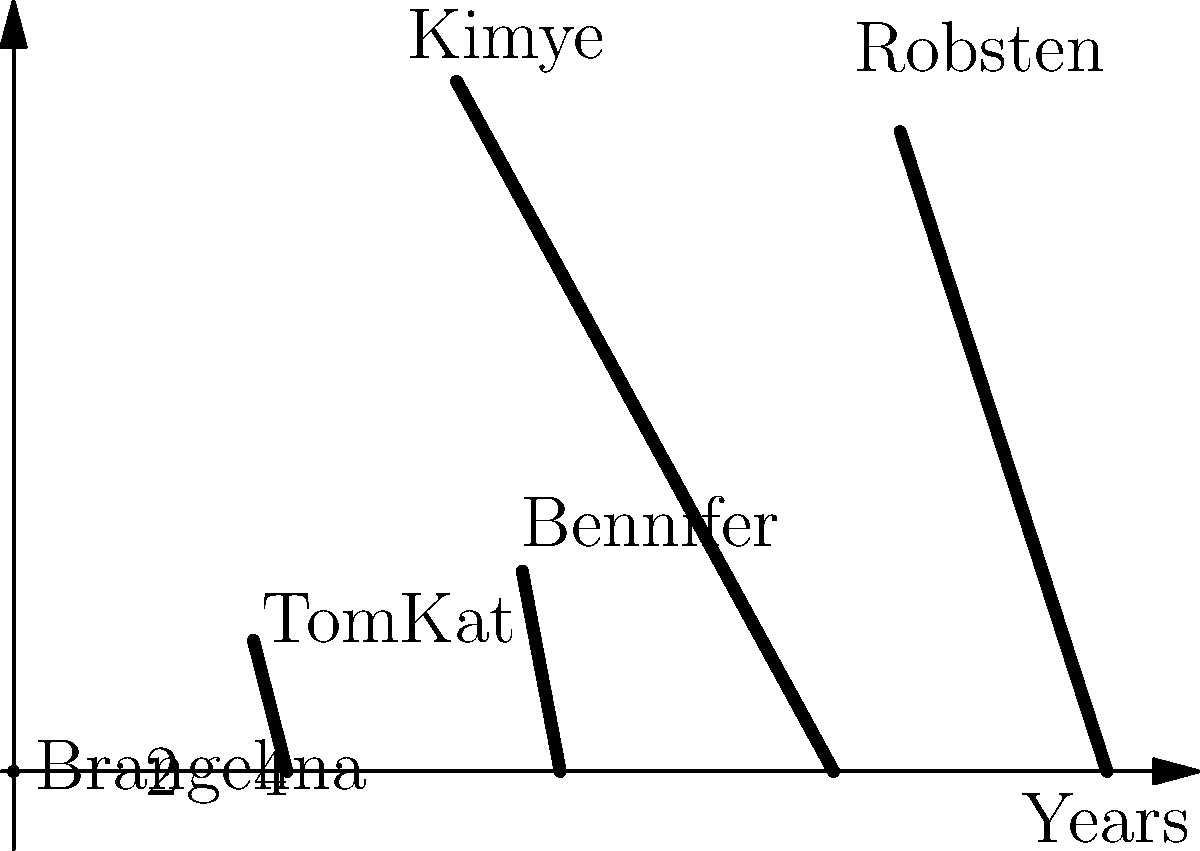In this polar coordinate visualization of celebrity relationship durations, which couple had the longest-lasting relationship, and approximately how many years did it last? To determine the longest-lasting celebrity relationship and its duration, we need to analyze the spiral arcs in the polar coordinate system:

1. Each spiral arc represents a celebrity couple's relationship duration.
2. The length of the arc corresponds to the relationship's duration in years.
3. The longest arc will represent the longest-lasting relationship.

Examining the diagram:

1. "Brangelina" (Brad Pitt and Angelina Jolie): Arc extends to about 3.5 units
2. "TomKat" (Tom Cruise and Katie Holmes): Arc extends to about 2 units
3. "Bennifer" (Ben Affleck and Jennifer Lopez): Arc extends to about 1.5 units
4. "Kimye" (Kim Kardashian and Kanye West): Arc extends to 4 units
5. "Robsten" (Robert Pattinson and Kristen Stewart): Arc extends to about 2.5 units

The longest arc belongs to "Kimye," which extends to 4 units on the scale. Since the scale represents years, we can conclude that Kim Kardashian and Kanye West's relationship lasted approximately 4 years.
Answer: Kimye, 4 years 